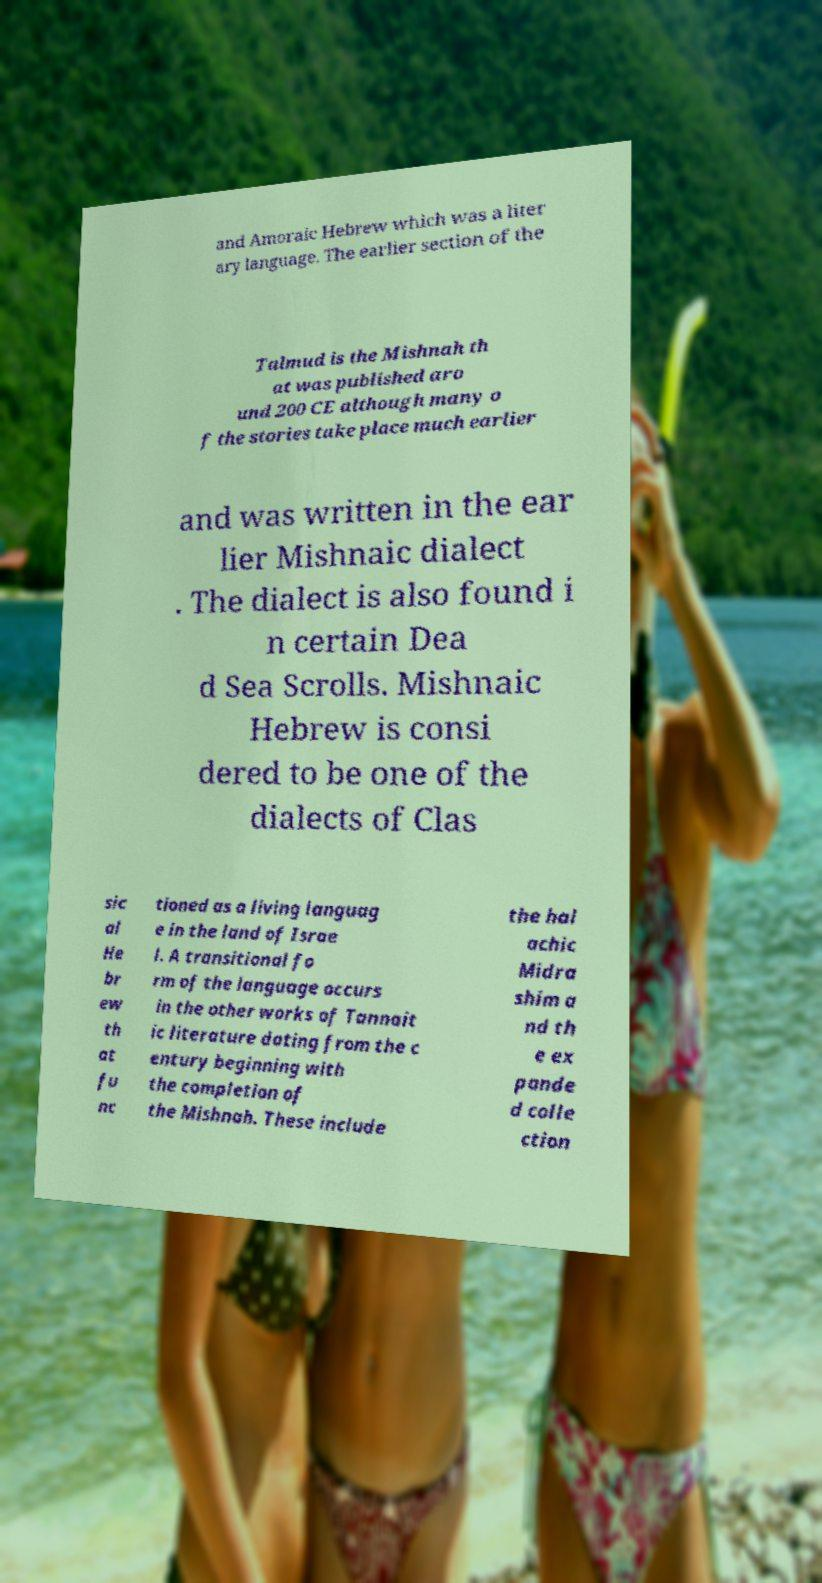Please read and relay the text visible in this image. What does it say? and Amoraic Hebrew which was a liter ary language. The earlier section of the Talmud is the Mishnah th at was published aro und 200 CE although many o f the stories take place much earlier and was written in the ear lier Mishnaic dialect . The dialect is also found i n certain Dea d Sea Scrolls. Mishnaic Hebrew is consi dered to be one of the dialects of Clas sic al He br ew th at fu nc tioned as a living languag e in the land of Israe l. A transitional fo rm of the language occurs in the other works of Tannait ic literature dating from the c entury beginning with the completion of the Mishnah. These include the hal achic Midra shim a nd th e ex pande d colle ction 